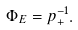Convert formula to latex. <formula><loc_0><loc_0><loc_500><loc_500>\Phi _ { E } = p _ { + } ^ { - 1 } .</formula> 